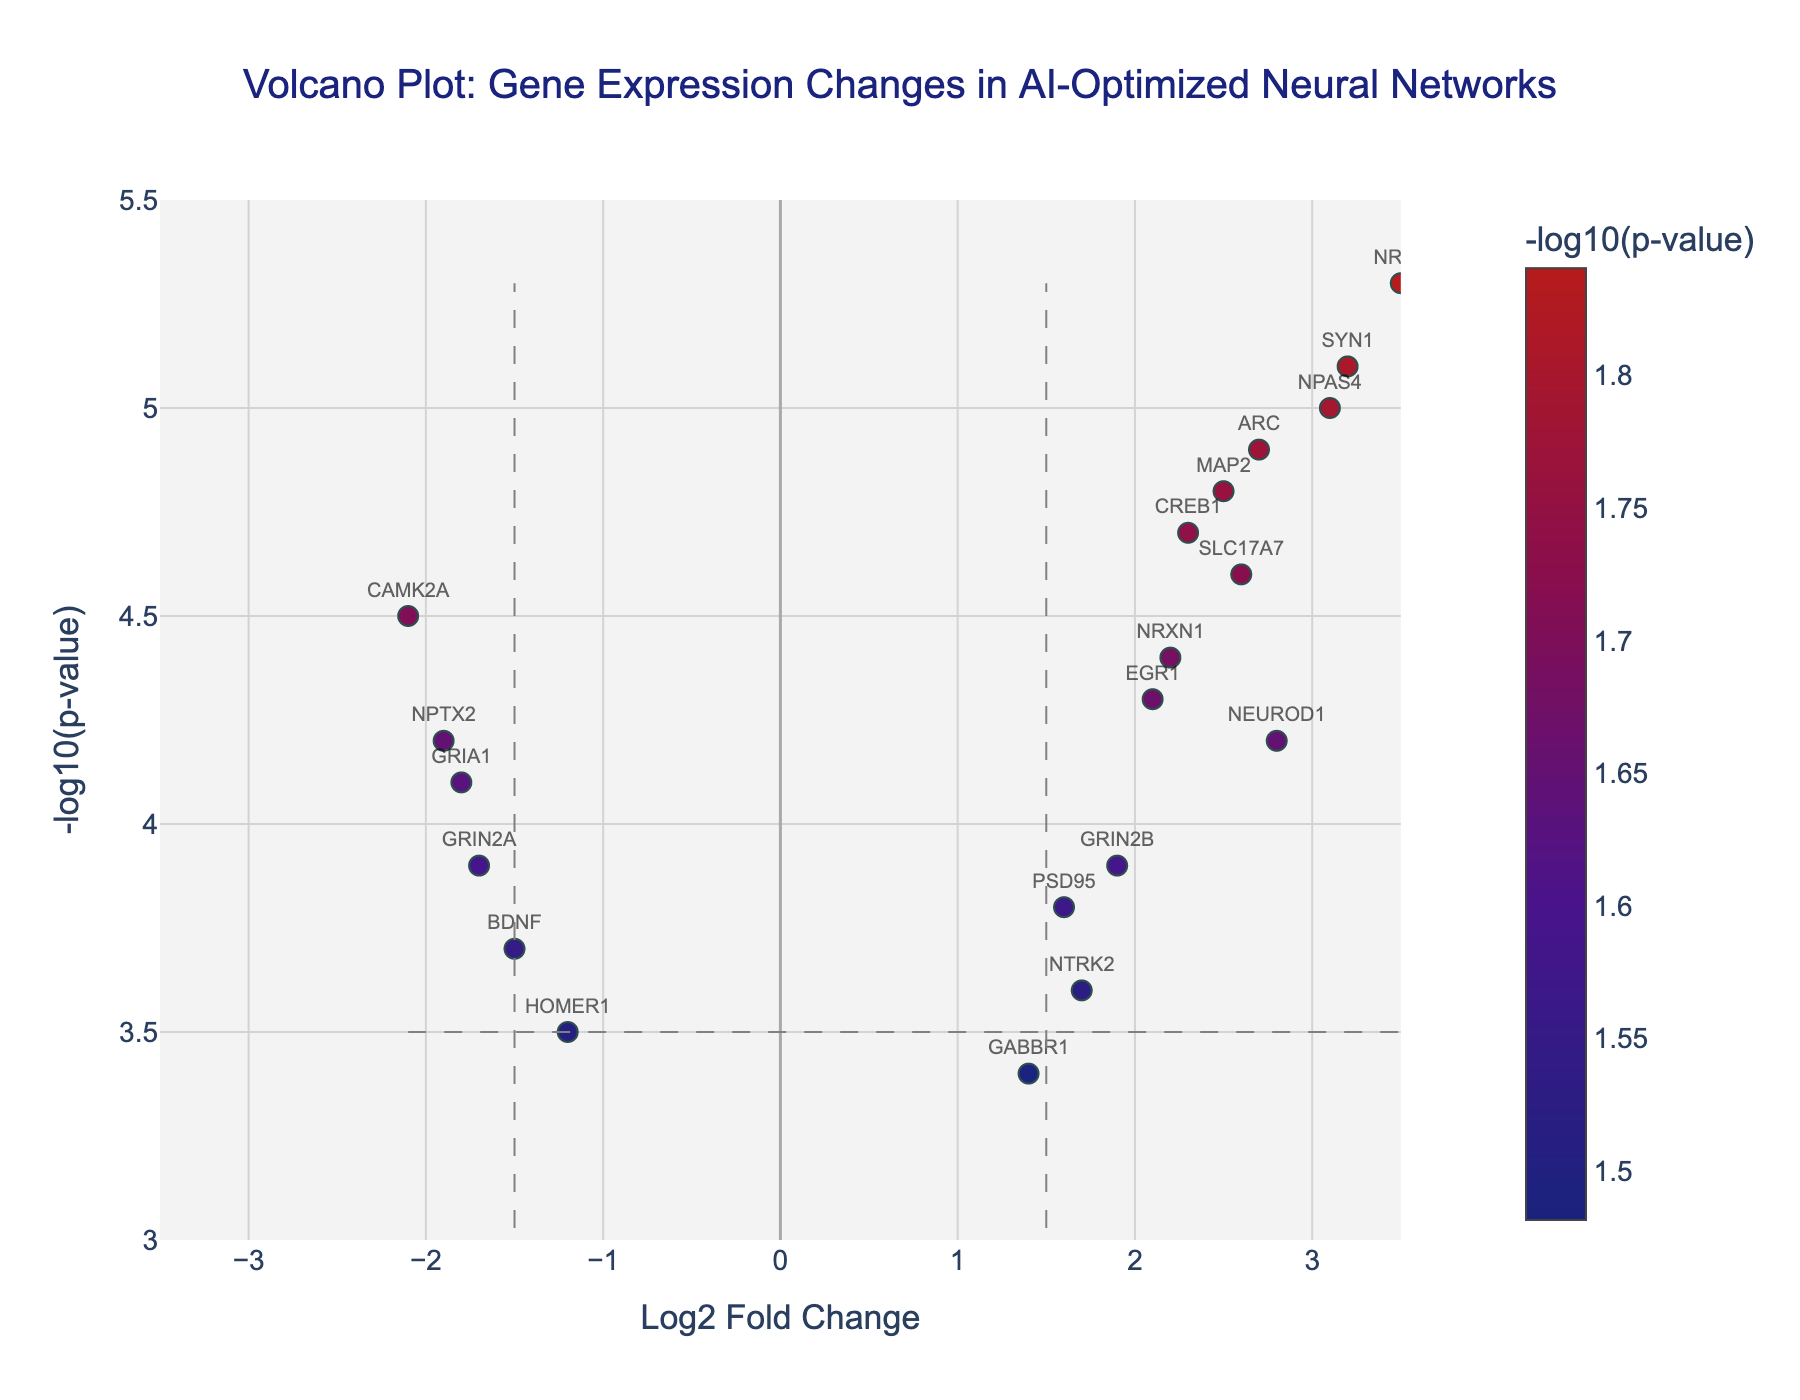What is the title of the plot? The title is located at the top of the volcano plot. It provides a summary of the contents or the main focus of the visualization.
Answer: Volcano Plot: Gene Expression Changes in AI-Optimized Neural Networks What does the x-axis represent? The x-axis represents the log2 fold change of gene expression, indicating the magnitude of change in gene expression levels between AI-optimized neural networks and traditional models.
Answer: Log2 Fold Change What does the y-axis represent? The y-axis represents the negative log10 p-value, which indicates the statistical significance of the observed changes in gene expression levels.
Answer: -log10(p-value) How many genes have a log2 fold change greater than 1.5? To find this, count the number of data points (genes) that have x-values (log2 fold change) greater than 1.5 on the plot.
Answer: 9 genes Which gene shows the highest negative log10 p-value? The gene with the highest negative log10 p-value can be identified as the highest point on the y-axis in the plot.
Answer: NRN1 Which gene shows the lowest log2 fold change? The gene with the lowest log2 fold change is the one positioned furthest to the left on the x-axis.
Answer: CAMK2A Which gene has both a log2 fold change greater than 1.5 and a negative log10 p-value greater than 4.5? Look for data points (genes) that satisfy both conditions: having an x-value greater than 1.5 and a y-value greater than 4.5.
Answer: SYN1 What is the range of log2 fold change values for genes that have a negative log10 p-value greater than 4.0? Identify the subset of genes where the y-value (negative log10 p-value) is greater than 4.0, then find the range of x-values (log2 fold change) for these genes. The range is the difference between the maximum and minimum values within this subset.
Answer: The range is -2.1 to 3.5 How many genes exhibit significant expression changes (log2 fold change > 1.5 and -log10 p-value > 3.5)? Count the number of genes that meet both criteria: having a log2 fold change greater than 1.5 and a negative log10 p-value greater than 3.5.
Answer: 10 genes Which two genes have the most similar log2 fold change values? Visually inspect the plot to find the pair of genes that are closest to each other along the x-axis (log2 fold change).
Answer: EGR1 and GRIN2B 